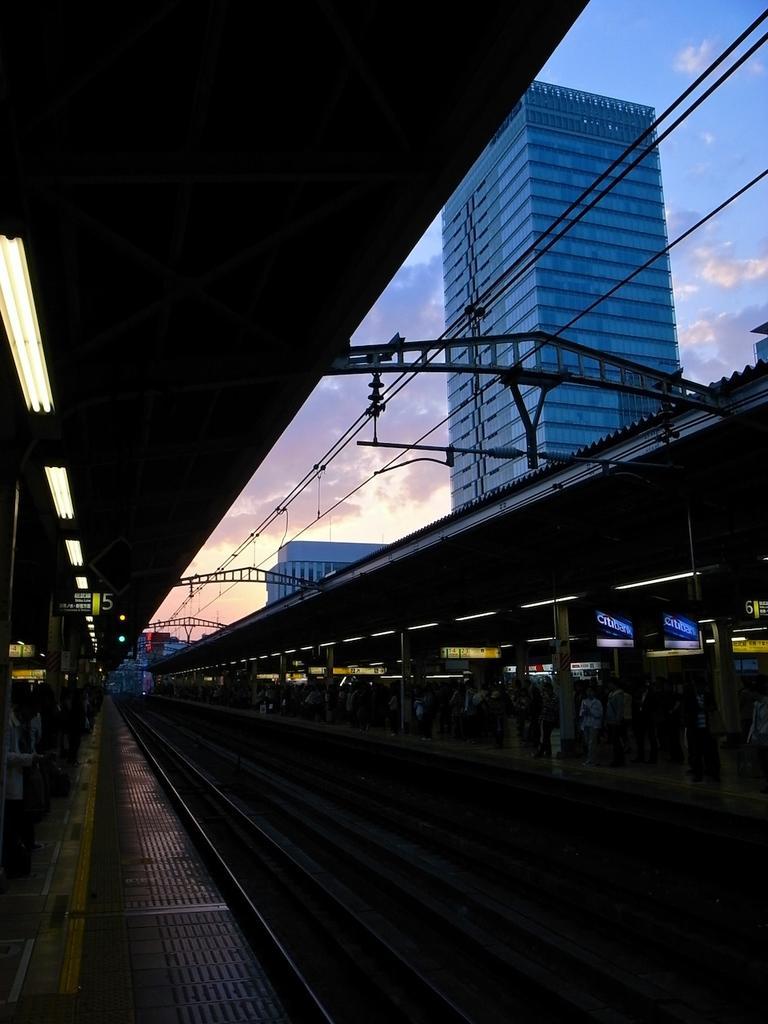In one or two sentences, can you explain what this image depicts? In the foreground I can see a track and a crowd on the platform. In the background I can see electric wires, buildings, rooftop and the sky. This image is taken may be on the platform. 